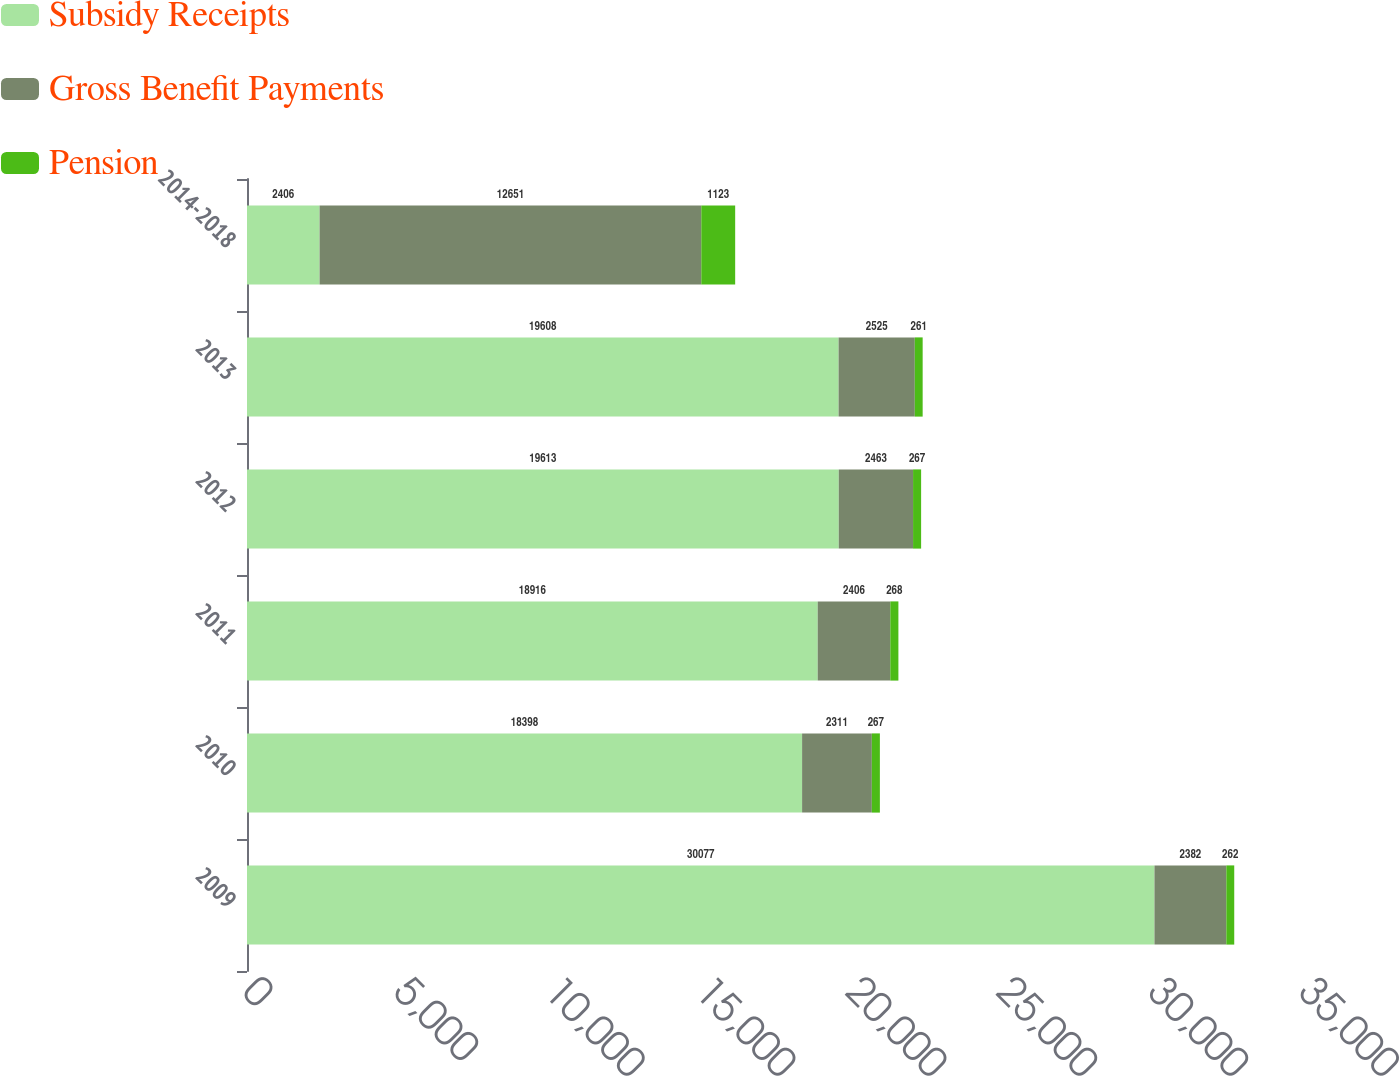Convert chart. <chart><loc_0><loc_0><loc_500><loc_500><stacked_bar_chart><ecel><fcel>2009<fcel>2010<fcel>2011<fcel>2012<fcel>2013<fcel>2014-2018<nl><fcel>Subsidy Receipts<fcel>30077<fcel>18398<fcel>18916<fcel>19613<fcel>19608<fcel>2406<nl><fcel>Gross Benefit Payments<fcel>2382<fcel>2311<fcel>2406<fcel>2463<fcel>2525<fcel>12651<nl><fcel>Pension<fcel>262<fcel>267<fcel>268<fcel>267<fcel>261<fcel>1123<nl></chart> 